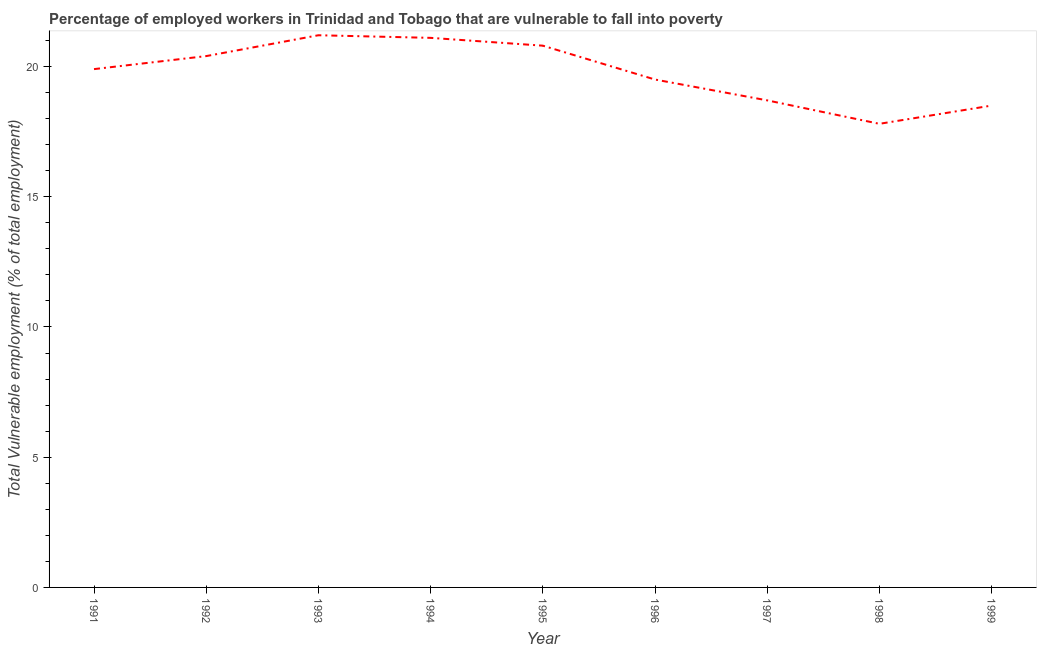What is the total vulnerable employment in 1997?
Offer a terse response. 18.7. Across all years, what is the maximum total vulnerable employment?
Provide a short and direct response. 21.2. Across all years, what is the minimum total vulnerable employment?
Your answer should be very brief. 17.8. What is the sum of the total vulnerable employment?
Keep it short and to the point. 177.9. What is the difference between the total vulnerable employment in 1993 and 1995?
Your answer should be compact. 0.4. What is the average total vulnerable employment per year?
Your answer should be compact. 19.77. What is the median total vulnerable employment?
Your answer should be compact. 19.9. Do a majority of the years between 1999 and 1996 (inclusive) have total vulnerable employment greater than 6 %?
Provide a succinct answer. Yes. What is the ratio of the total vulnerable employment in 1994 to that in 1997?
Ensure brevity in your answer.  1.13. Is the total vulnerable employment in 1993 less than that in 1995?
Offer a very short reply. No. Is the difference between the total vulnerable employment in 1998 and 1999 greater than the difference between any two years?
Offer a very short reply. No. What is the difference between the highest and the second highest total vulnerable employment?
Give a very brief answer. 0.1. What is the difference between the highest and the lowest total vulnerable employment?
Your response must be concise. 3.4. In how many years, is the total vulnerable employment greater than the average total vulnerable employment taken over all years?
Offer a very short reply. 5. Are the values on the major ticks of Y-axis written in scientific E-notation?
Keep it short and to the point. No. What is the title of the graph?
Provide a short and direct response. Percentage of employed workers in Trinidad and Tobago that are vulnerable to fall into poverty. What is the label or title of the Y-axis?
Make the answer very short. Total Vulnerable employment (% of total employment). What is the Total Vulnerable employment (% of total employment) of 1991?
Ensure brevity in your answer.  19.9. What is the Total Vulnerable employment (% of total employment) in 1992?
Your answer should be very brief. 20.4. What is the Total Vulnerable employment (% of total employment) in 1993?
Ensure brevity in your answer.  21.2. What is the Total Vulnerable employment (% of total employment) in 1994?
Your answer should be very brief. 21.1. What is the Total Vulnerable employment (% of total employment) of 1995?
Your answer should be very brief. 20.8. What is the Total Vulnerable employment (% of total employment) in 1997?
Keep it short and to the point. 18.7. What is the Total Vulnerable employment (% of total employment) in 1998?
Provide a succinct answer. 17.8. What is the Total Vulnerable employment (% of total employment) of 1999?
Your answer should be compact. 18.5. What is the difference between the Total Vulnerable employment (% of total employment) in 1991 and 1992?
Provide a succinct answer. -0.5. What is the difference between the Total Vulnerable employment (% of total employment) in 1991 and 1993?
Your answer should be compact. -1.3. What is the difference between the Total Vulnerable employment (% of total employment) in 1991 and 1995?
Your response must be concise. -0.9. What is the difference between the Total Vulnerable employment (% of total employment) in 1991 and 1998?
Provide a short and direct response. 2.1. What is the difference between the Total Vulnerable employment (% of total employment) in 1991 and 1999?
Ensure brevity in your answer.  1.4. What is the difference between the Total Vulnerable employment (% of total employment) in 1992 and 1994?
Your answer should be very brief. -0.7. What is the difference between the Total Vulnerable employment (% of total employment) in 1992 and 1996?
Your answer should be very brief. 0.9. What is the difference between the Total Vulnerable employment (% of total employment) in 1992 and 1998?
Your answer should be compact. 2.6. What is the difference between the Total Vulnerable employment (% of total employment) in 1993 and 1994?
Your response must be concise. 0.1. What is the difference between the Total Vulnerable employment (% of total employment) in 1993 and 1996?
Your answer should be very brief. 1.7. What is the difference between the Total Vulnerable employment (% of total employment) in 1993 and 1997?
Provide a succinct answer. 2.5. What is the difference between the Total Vulnerable employment (% of total employment) in 1993 and 1998?
Keep it short and to the point. 3.4. What is the difference between the Total Vulnerable employment (% of total employment) in 1993 and 1999?
Make the answer very short. 2.7. What is the difference between the Total Vulnerable employment (% of total employment) in 1994 and 1995?
Offer a very short reply. 0.3. What is the difference between the Total Vulnerable employment (% of total employment) in 1994 and 1998?
Make the answer very short. 3.3. What is the difference between the Total Vulnerable employment (% of total employment) in 1995 and 1998?
Ensure brevity in your answer.  3. What is the difference between the Total Vulnerable employment (% of total employment) in 1997 and 1998?
Offer a very short reply. 0.9. What is the difference between the Total Vulnerable employment (% of total employment) in 1998 and 1999?
Your response must be concise. -0.7. What is the ratio of the Total Vulnerable employment (% of total employment) in 1991 to that in 1992?
Ensure brevity in your answer.  0.97. What is the ratio of the Total Vulnerable employment (% of total employment) in 1991 to that in 1993?
Offer a very short reply. 0.94. What is the ratio of the Total Vulnerable employment (% of total employment) in 1991 to that in 1994?
Provide a succinct answer. 0.94. What is the ratio of the Total Vulnerable employment (% of total employment) in 1991 to that in 1997?
Make the answer very short. 1.06. What is the ratio of the Total Vulnerable employment (% of total employment) in 1991 to that in 1998?
Ensure brevity in your answer.  1.12. What is the ratio of the Total Vulnerable employment (% of total employment) in 1991 to that in 1999?
Make the answer very short. 1.08. What is the ratio of the Total Vulnerable employment (% of total employment) in 1992 to that in 1994?
Offer a terse response. 0.97. What is the ratio of the Total Vulnerable employment (% of total employment) in 1992 to that in 1995?
Your response must be concise. 0.98. What is the ratio of the Total Vulnerable employment (% of total employment) in 1992 to that in 1996?
Ensure brevity in your answer.  1.05. What is the ratio of the Total Vulnerable employment (% of total employment) in 1992 to that in 1997?
Ensure brevity in your answer.  1.09. What is the ratio of the Total Vulnerable employment (% of total employment) in 1992 to that in 1998?
Offer a very short reply. 1.15. What is the ratio of the Total Vulnerable employment (% of total employment) in 1992 to that in 1999?
Provide a succinct answer. 1.1. What is the ratio of the Total Vulnerable employment (% of total employment) in 1993 to that in 1995?
Your answer should be very brief. 1.02. What is the ratio of the Total Vulnerable employment (% of total employment) in 1993 to that in 1996?
Make the answer very short. 1.09. What is the ratio of the Total Vulnerable employment (% of total employment) in 1993 to that in 1997?
Offer a very short reply. 1.13. What is the ratio of the Total Vulnerable employment (% of total employment) in 1993 to that in 1998?
Your response must be concise. 1.19. What is the ratio of the Total Vulnerable employment (% of total employment) in 1993 to that in 1999?
Offer a very short reply. 1.15. What is the ratio of the Total Vulnerable employment (% of total employment) in 1994 to that in 1996?
Provide a succinct answer. 1.08. What is the ratio of the Total Vulnerable employment (% of total employment) in 1994 to that in 1997?
Ensure brevity in your answer.  1.13. What is the ratio of the Total Vulnerable employment (% of total employment) in 1994 to that in 1998?
Make the answer very short. 1.19. What is the ratio of the Total Vulnerable employment (% of total employment) in 1994 to that in 1999?
Your answer should be compact. 1.14. What is the ratio of the Total Vulnerable employment (% of total employment) in 1995 to that in 1996?
Your answer should be compact. 1.07. What is the ratio of the Total Vulnerable employment (% of total employment) in 1995 to that in 1997?
Keep it short and to the point. 1.11. What is the ratio of the Total Vulnerable employment (% of total employment) in 1995 to that in 1998?
Your answer should be very brief. 1.17. What is the ratio of the Total Vulnerable employment (% of total employment) in 1995 to that in 1999?
Ensure brevity in your answer.  1.12. What is the ratio of the Total Vulnerable employment (% of total employment) in 1996 to that in 1997?
Make the answer very short. 1.04. What is the ratio of the Total Vulnerable employment (% of total employment) in 1996 to that in 1998?
Keep it short and to the point. 1.1. What is the ratio of the Total Vulnerable employment (% of total employment) in 1996 to that in 1999?
Your answer should be compact. 1.05. What is the ratio of the Total Vulnerable employment (% of total employment) in 1997 to that in 1998?
Provide a succinct answer. 1.05. What is the ratio of the Total Vulnerable employment (% of total employment) in 1997 to that in 1999?
Offer a terse response. 1.01. What is the ratio of the Total Vulnerable employment (% of total employment) in 1998 to that in 1999?
Your answer should be very brief. 0.96. 